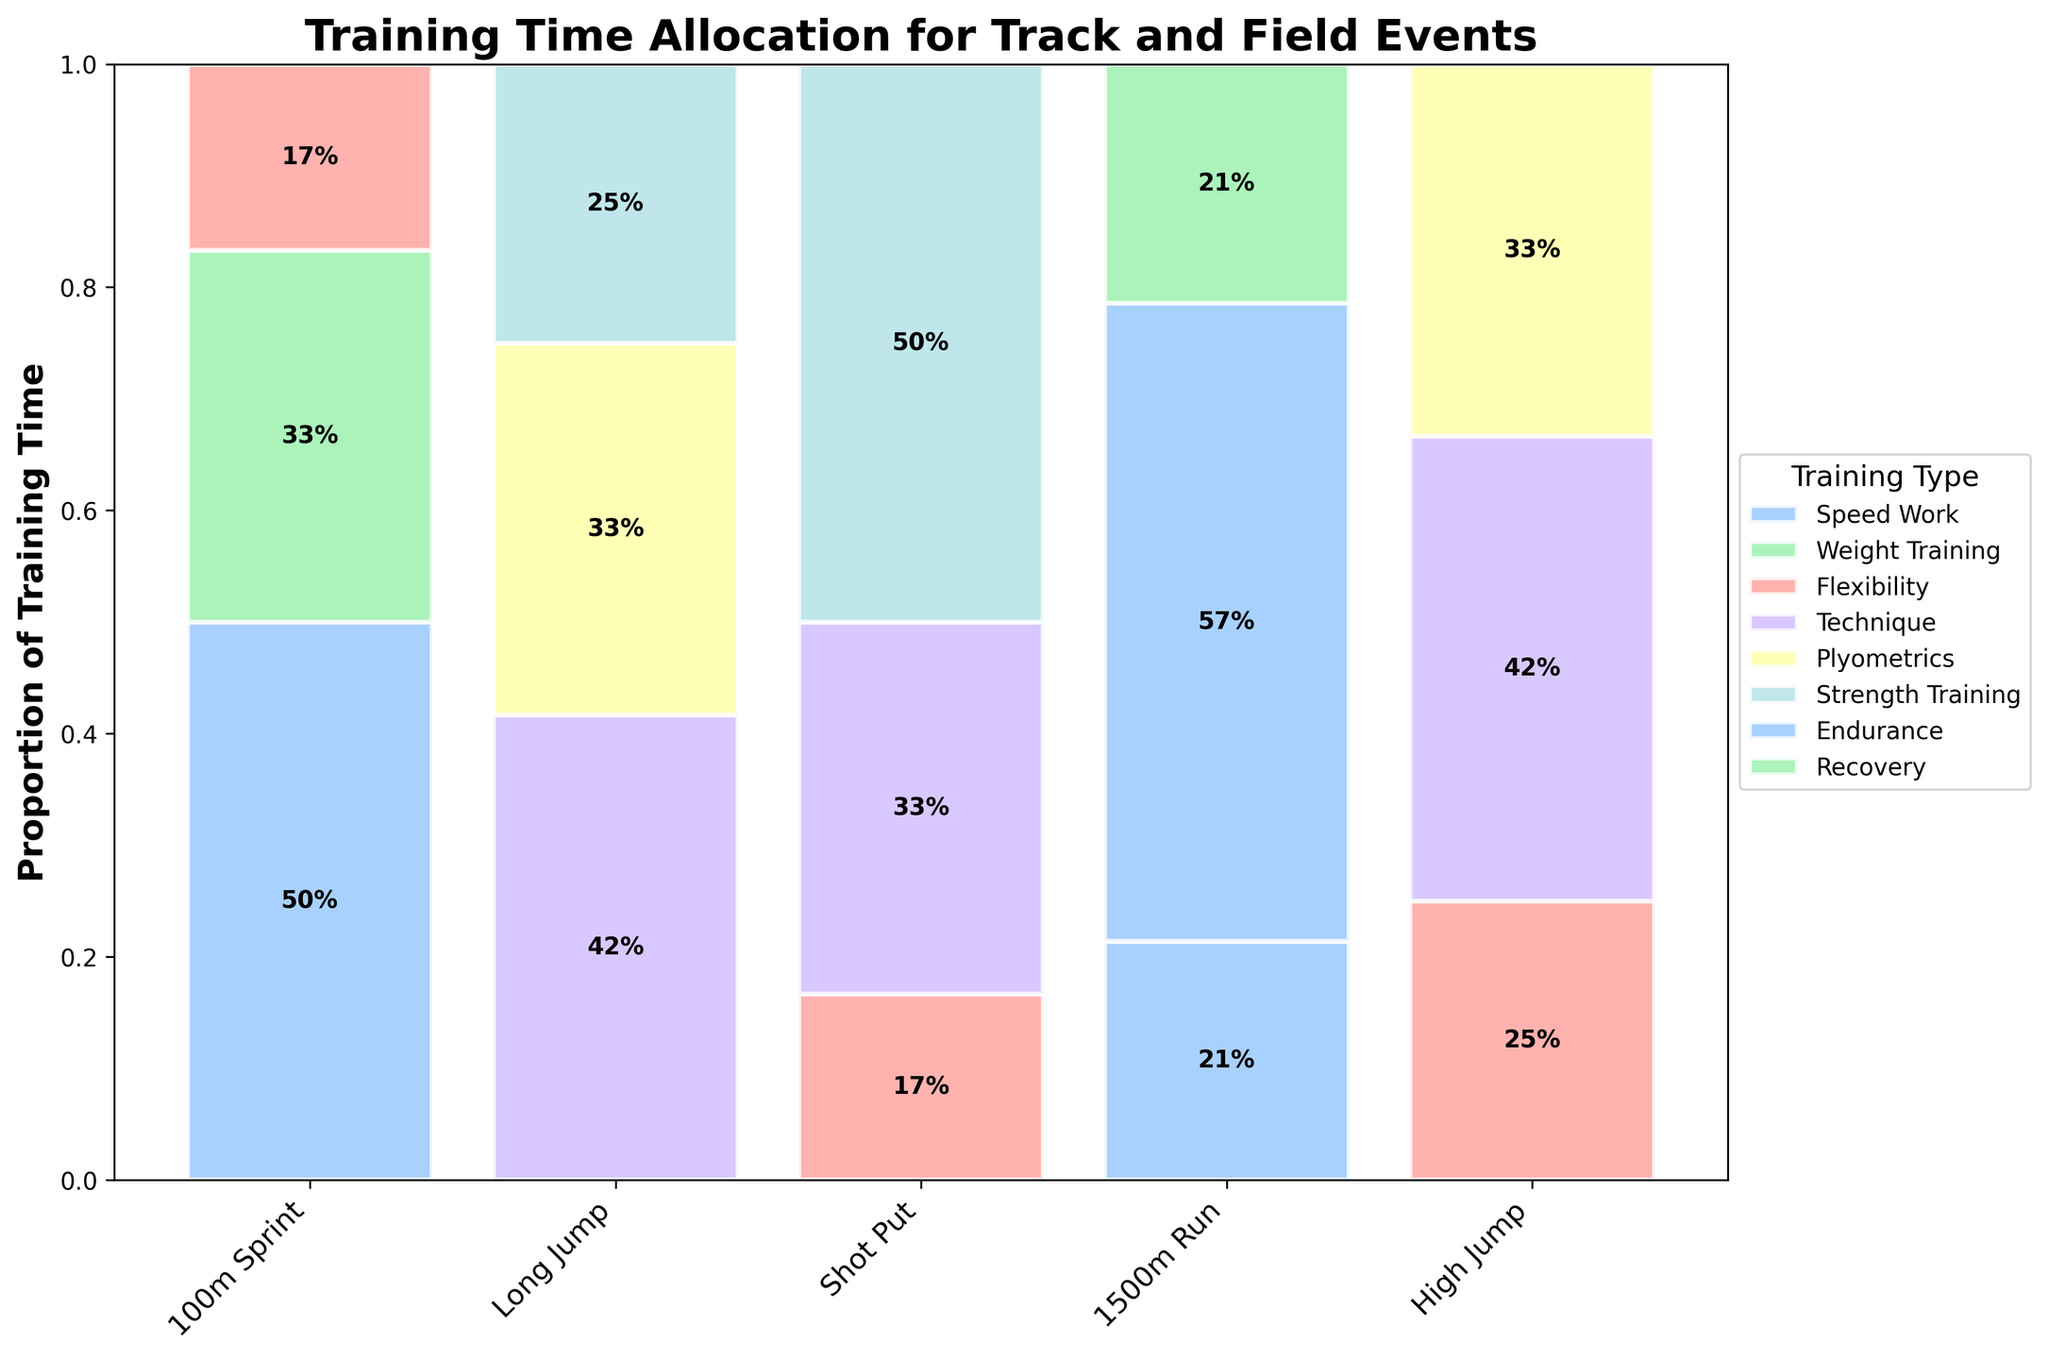What's the title of the figure? The title of a figure is typically found at the top of the plot, describing its content and purpose.
Answer: Training Time Allocation for Track and Field Events How many track and field events are compared in the figure? The number of events can be identified by counting the unique labels along the x-axis.
Answer: 5 Which event has the highest proportion of "Endurance" training? To find this, look at the segment labeled "Endurance" and see which event's bar has the largest segment.
Answer: 1500m Run What's the proportion of "Technique" training for the High Jump event? Locate the High Jump bar and identify the "Technique" segment. Read the height of this segment for its proportion.
Answer: 42% How does "Speed Work" training for the 100m Sprint compare to "Flexibility" training for the same event? Look at the 100m Sprint bar and compare the heights of the segments labeled "Speed Work" and "Flexibility."
Answer: Speed Work is significantly higher than Flexibility Which training type is most emphasized for the Shot Put event? Identify the Shot Put bar and observe which training type segment is the tallest.
Answer: Strength Training Compare the proportion of "Plyometrics" training between Long Jump and High Jump. Which event's bar has a taller segment for "Plyometrics"? Examine both the Long Jump and High Jump bars for the "Plyometrics" segment and note which one is higher.
Answer: Tie (both are equal) What is the least emphasized training type for the 1500m Run? Check the 1500m Run bar and find the segment with the smallest proportion.
Answer: Speed Work and Recovery (tied) What's the total proportion of "Flexibility" training across all events? Sum the proportions of "Flexibility" segments from all events' bars. Convert the values into a single total percentage.
Answer: Approx. 12% Which two events have the same proportion of "Strength Training"? Identify the events that have "Strength Training" bars of equal height by comparing the relevant segments across different events.
Answer: Long Jump and Shot Put 